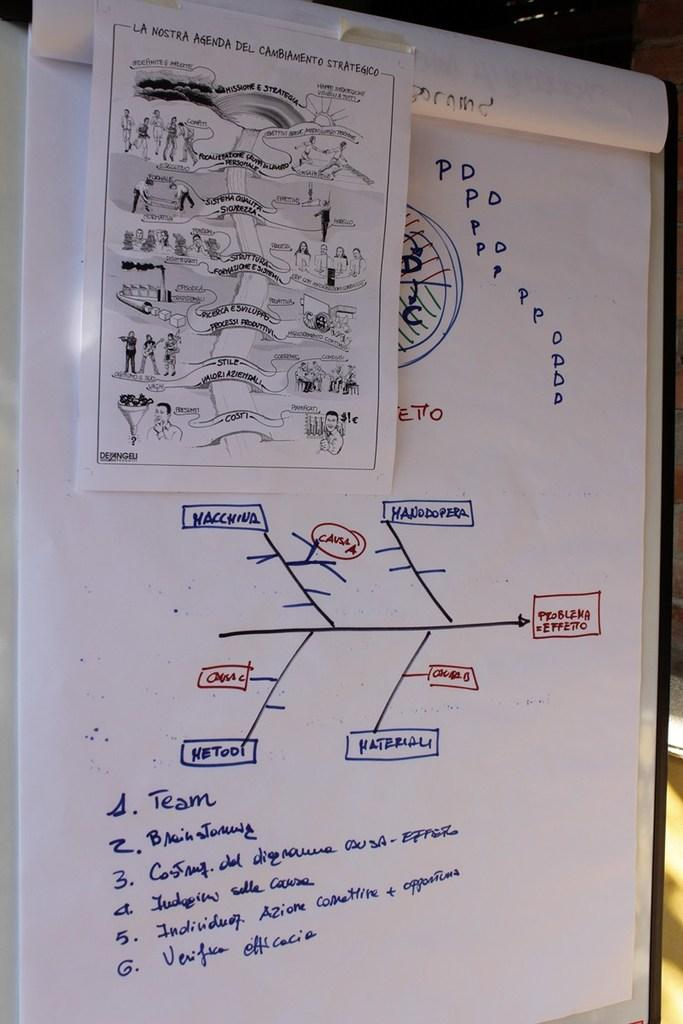What is the main object in the image? There is a board in the image. What is attached to the board? Sheets are attached to the board. What can be found on the sheets? There are pictures on the sheets. Is there any additional information on the sheets? A small paper is attached to one of the sheets. What does your uncle say about the worm in the image? There is no uncle or worm present in the image. 